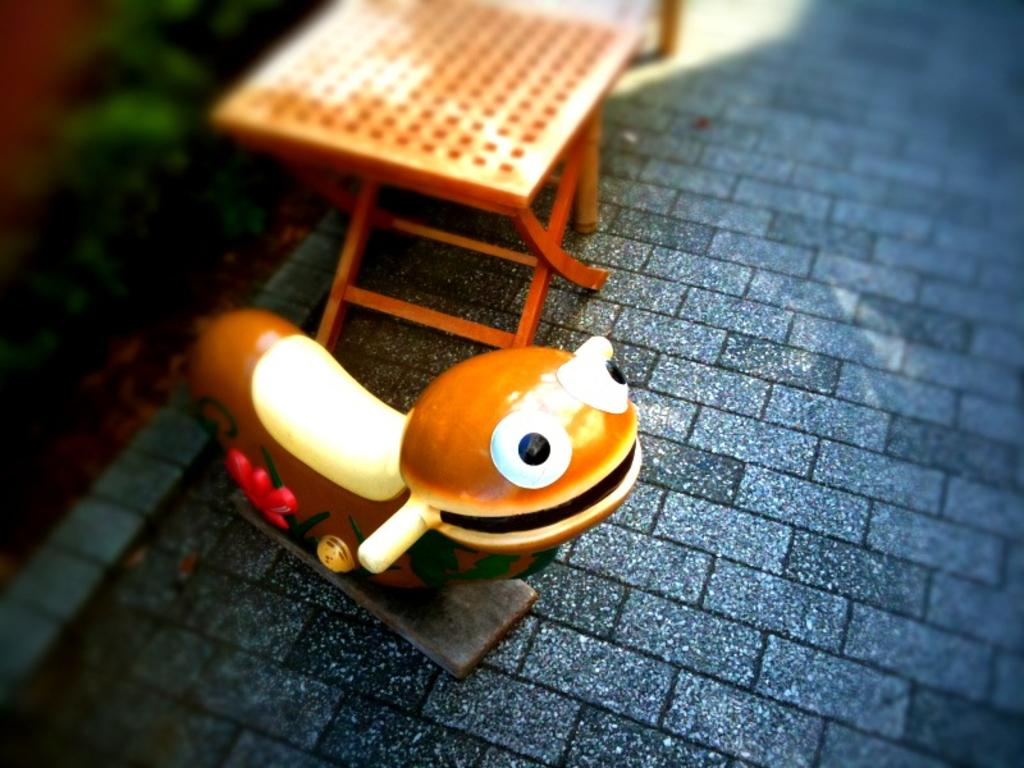What is on the floor in the image? There is a toy on the floor. What piece of furniture is present in the image? There is a table in the image. What can be seen in the background of the image? Trees are visible in the background of the image. What type of humor is being displayed by the lawyer in the image? There is no lawyer present in the image, so it is not possible to determine what type of humor might be displayed. 